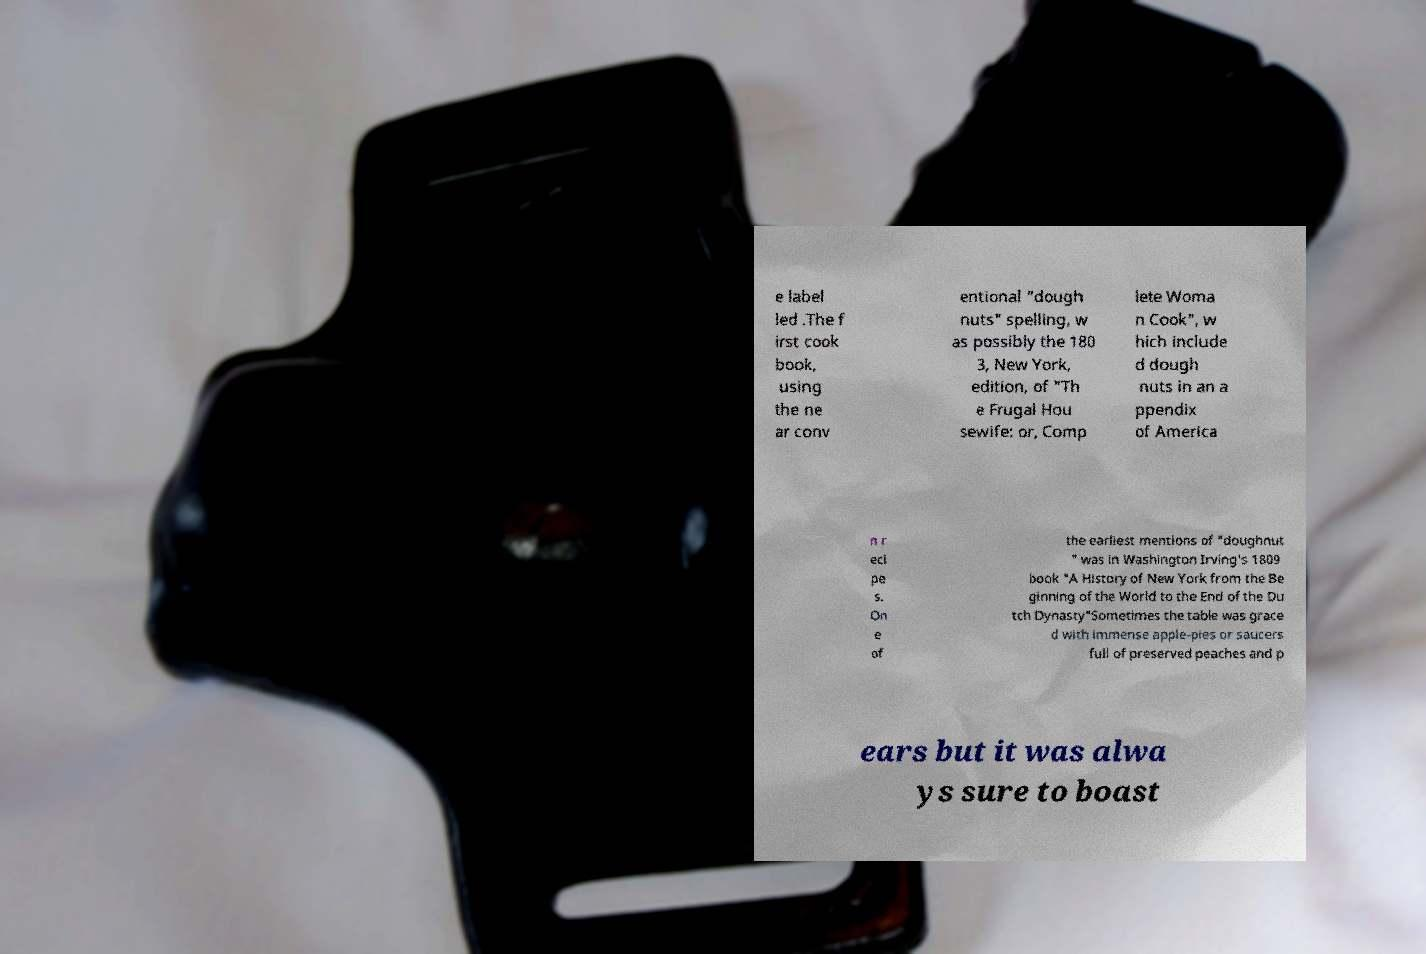There's text embedded in this image that I need extracted. Can you transcribe it verbatim? e label led .The f irst cook book, using the ne ar conv entional "dough nuts" spelling, w as possibly the 180 3, New York, edition, of "Th e Frugal Hou sewife: or, Comp lete Woma n Cook", w hich include d dough nuts in an a ppendix of America n r eci pe s. On e of the earliest mentions of "doughnut " was in Washington Irving's 1809 book "A History of New York from the Be ginning of the World to the End of the Du tch Dynasty"Sometimes the table was grace d with immense apple-pies or saucers full of preserved peaches and p ears but it was alwa ys sure to boast 